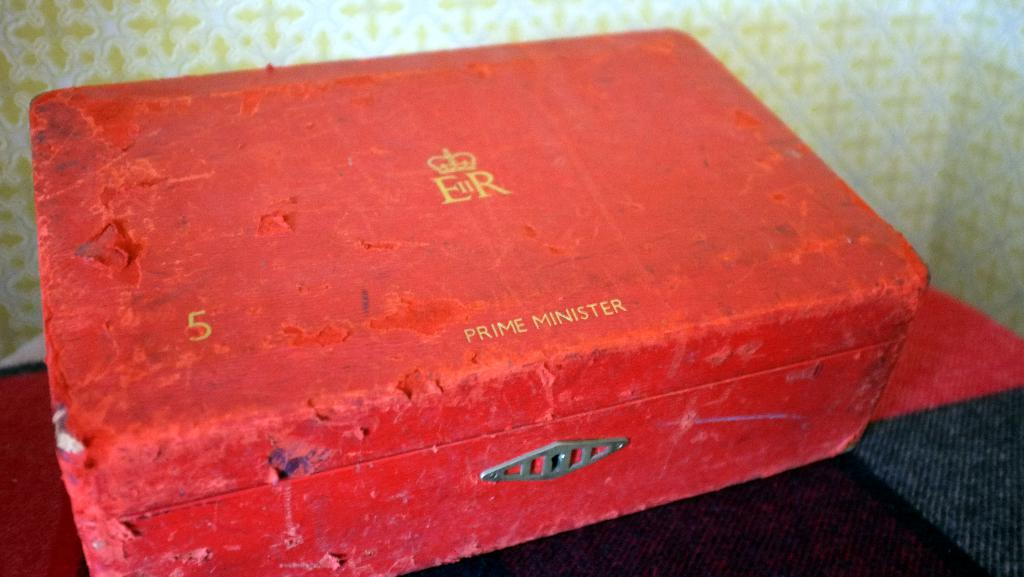<image>
Give a short and clear explanation of the subsequent image. A worn red box has 'Prime Minister' on the top. 